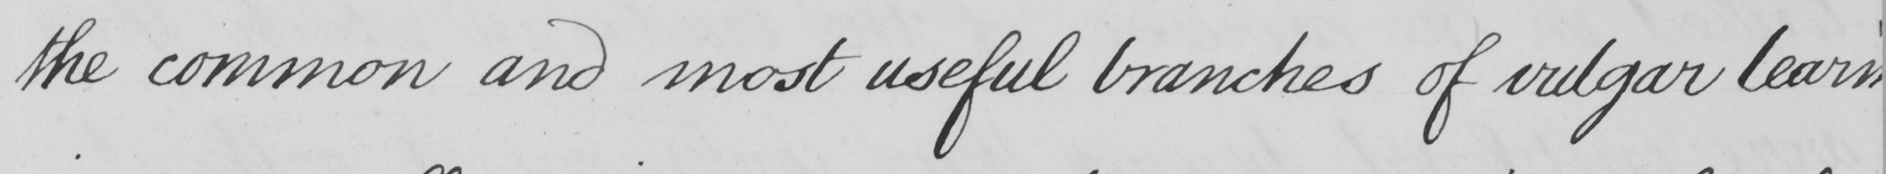Can you tell me what this handwritten text says? the common and most useful branches of vulgar learn- 